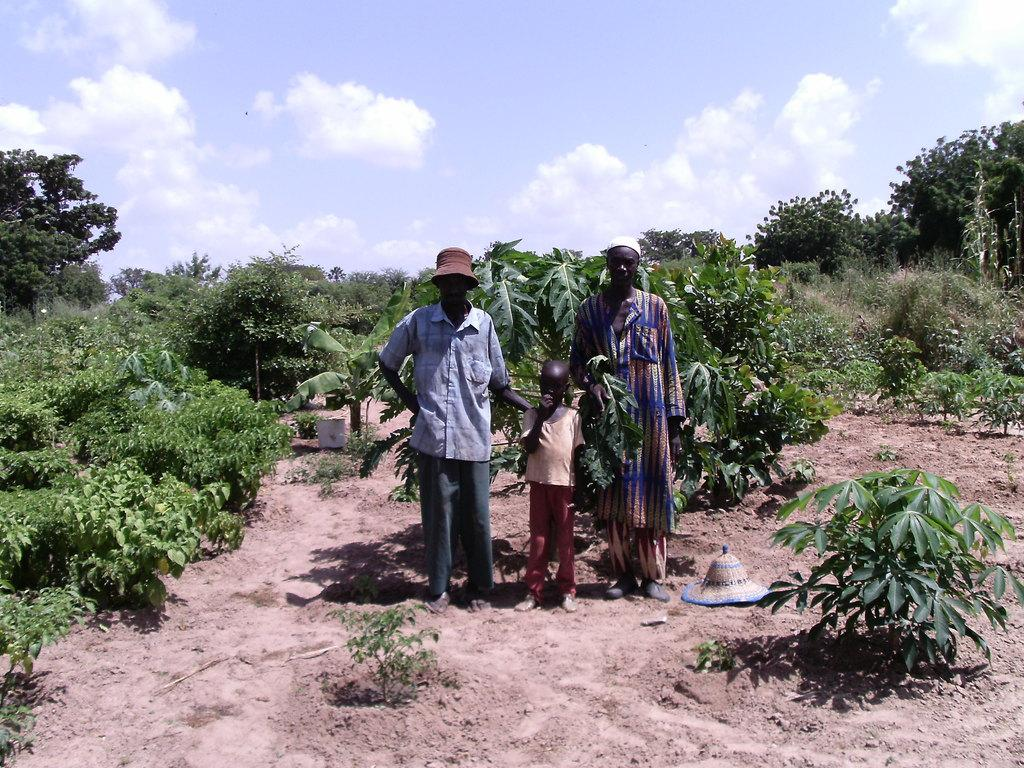How many people are present in the image? There are three persons standing in the image. What can be seen besides the people in the image? There are plants, trees, and sand visible in the image. Can you describe the headwear of one of the persons? At least one person is wearing a cap. What is visible in the background of the image? The sky is visible in the background of the image. What color is the ship in the image? There is no ship present in the image. What team are the people in the image supporting? There is no indication of a team or any sports-related activity in the image. 